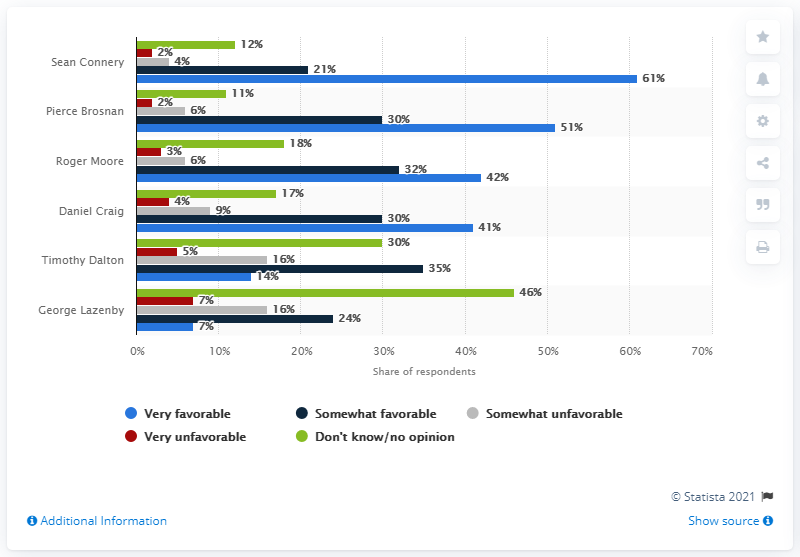Identify some key points in this picture. The majority of respondents stated that they did not know or had no opinion about George Lazenby. Sean Connery was considered the most favorable James Bond actor by many people. 